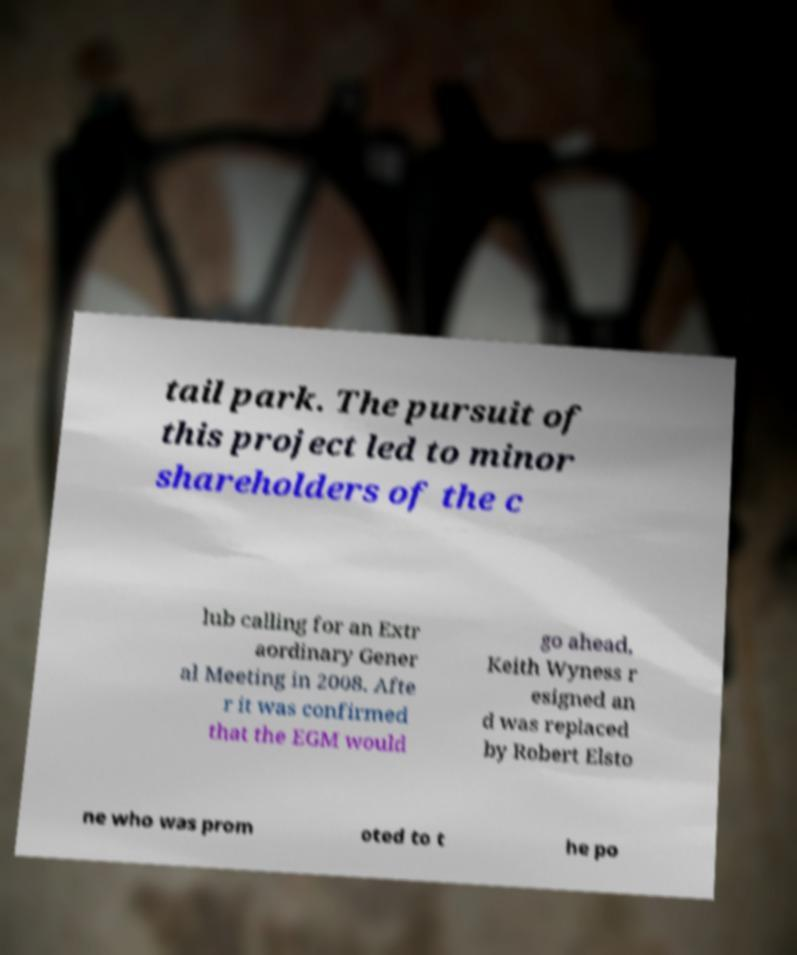I need the written content from this picture converted into text. Can you do that? tail park. The pursuit of this project led to minor shareholders of the c lub calling for an Extr aordinary Gener al Meeting in 2008. Afte r it was confirmed that the EGM would go ahead, Keith Wyness r esigned an d was replaced by Robert Elsto ne who was prom oted to t he po 